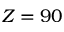Convert formula to latex. <formula><loc_0><loc_0><loc_500><loc_500>Z = 9 0</formula> 